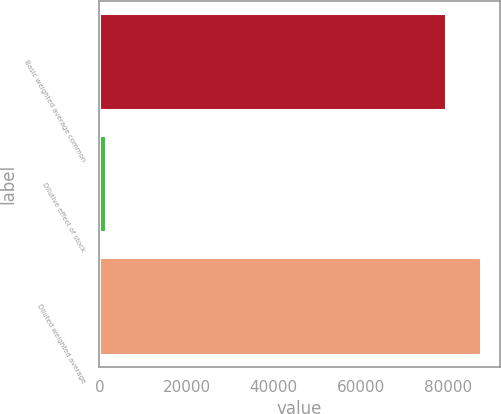Convert chart to OTSL. <chart><loc_0><loc_0><loc_500><loc_500><bar_chart><fcel>Basic weighted average common<fcel>Dilutive effect of stock<fcel>Diluted weighted average<nl><fcel>79527<fcel>1449<fcel>87479.7<nl></chart> 